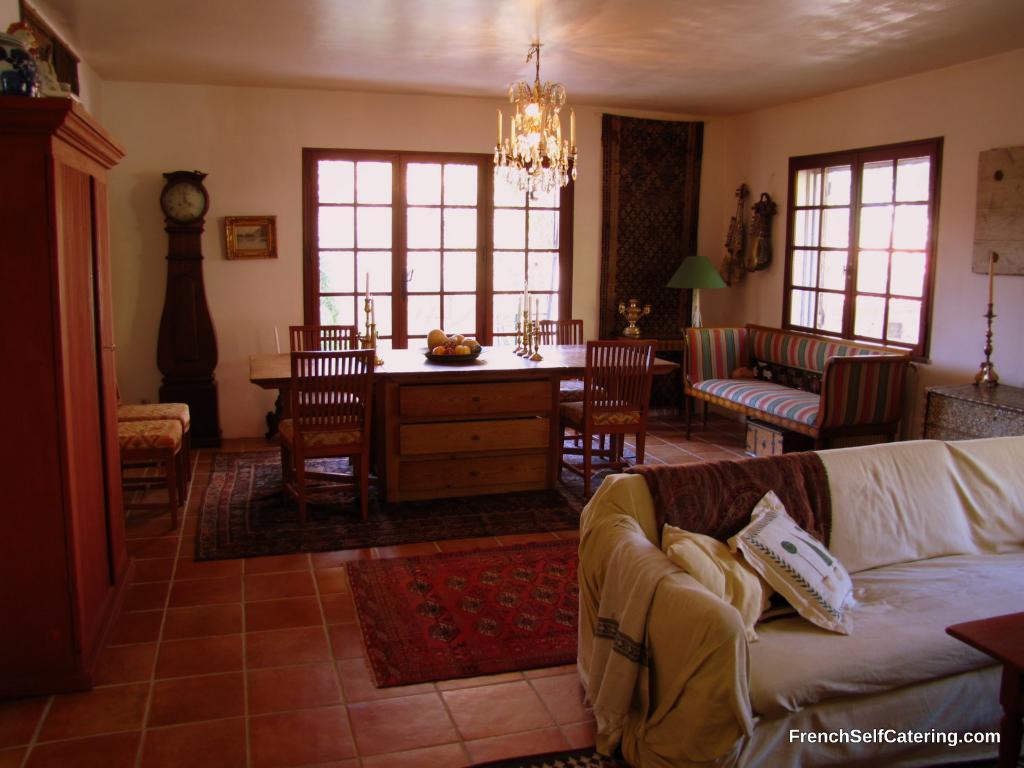Can you describe this image briefly? In this image I can see a table and few chairs. Here in the background I can see a clock and a frame on this wall. I can also see few sofas and cushions. 